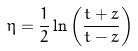<formula> <loc_0><loc_0><loc_500><loc_500>\eta = \frac { 1 } { 2 } \ln \left ( \frac { t + z } { t - z } \right )</formula> 